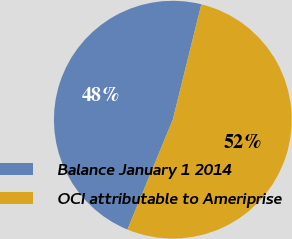Convert chart to OTSL. <chart><loc_0><loc_0><loc_500><loc_500><pie_chart><fcel>Balance January 1 2014<fcel>OCI attributable to Ameriprise<nl><fcel>47.62%<fcel>52.38%<nl></chart> 